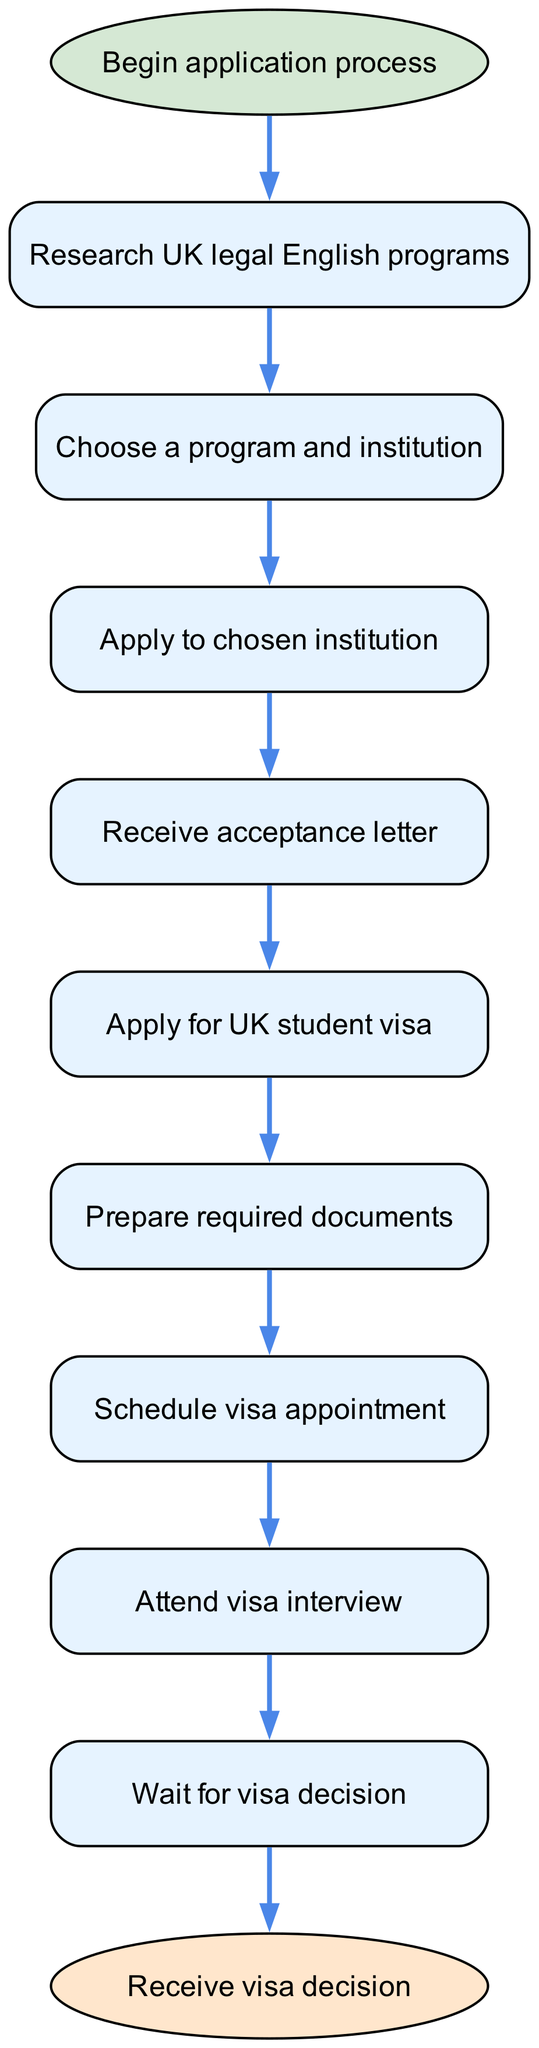What is the first step in obtaining a student visa? The first step in the diagram, indicated directly after the start node, is to "Research UK legal English programs."
Answer: Research UK legal English programs How many nodes are present in the diagram? By counting the number of unique steps listed in the nodes, there are a total of 9 nodes in the diagram.
Answer: 9 What follows after receiving the acceptance letter? The acceptance letter node is followed by the action of applying for a UK student visa. This is determined by following the edge from node 4 to node 5.
Answer: Apply for UK student visa What is the final step in the procedure? The final step indicated in the diagram is "Receive visa decision," which is connected to the last node before the end node.
Answer: Receive visa decision What must you do after scheduling a visa appointment? After scheduling the visa appointment, the next step is to attend the visa interview, which is established by the edge connecting node 7 to node 8.
Answer: Attend visa interview How many edges are connected to the apply for UK student visa node? The "Apply for UK student visa" node has one outgoing edge, leading to the "Prepare required documents" node. This is determined by checking edges connected to node 5.
Answer: 1 If a student receives an acceptance letter, what must they do next? Upon receiving the acceptance letter, the next action required is to apply for a UK student visa, as indicated by the transition from node 4 to node 5.
Answer: Apply for UK student visa What is the document preparation step related to? The "Prepare required documents" step is related to the student visa application process, as it directly follows the application for a UK student visa indicated in the diagram.
Answer: Student visa application process What is the relationship between the research step and the acceptance letter step? The relationship between these steps is sequential; after researching UK legal English programs, the student selects a program leading to the application and eventually to receiving an acceptance letter. This connective flow can be tracked from start to end through several edges in the diagram.
Answer: Sequential steps (research → application → acceptance letter) 